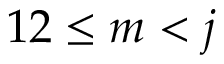Convert formula to latex. <formula><loc_0><loc_0><loc_500><loc_500>1 2 \leq m < j</formula> 